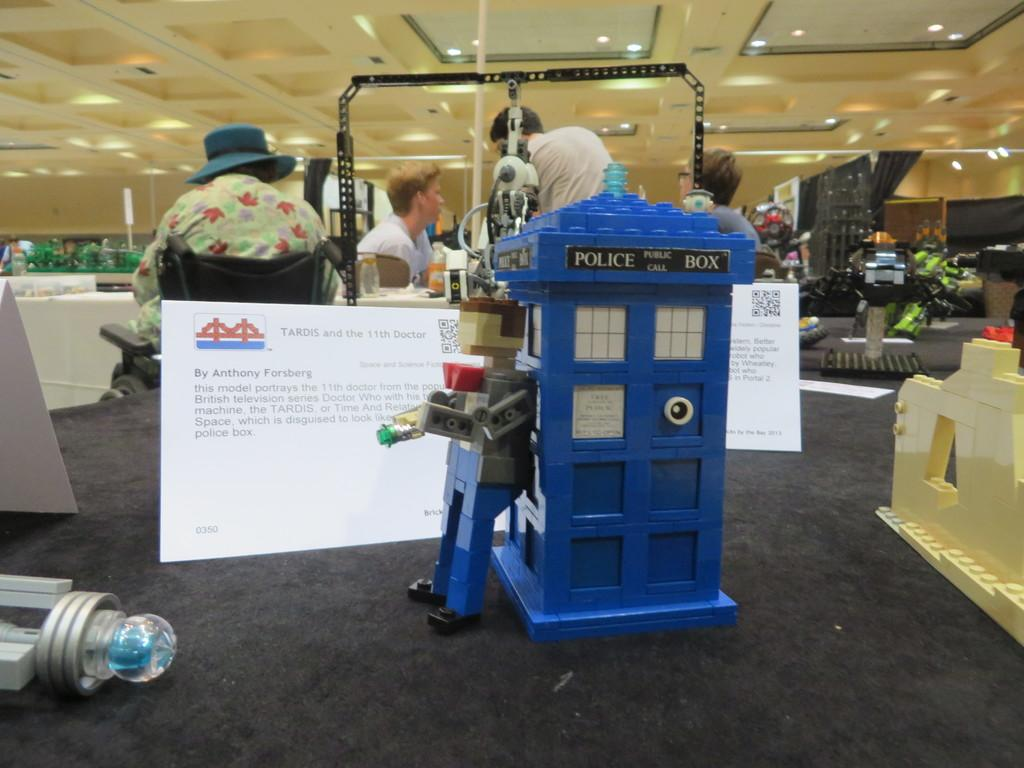What type of objects can be seen in the image? There are toys and paper notes in the image. Are there any people visible in the image? Yes, people are present in the image. What other objects can be seen in the image besides toys and paper notes? There are other objects in the image. What can be seen at the top of the image? There are lights visible at the top of the image. What type of food is being prepared in the image? There is no food preparation visible in the image. Can you describe the wax sculpture in the image? There is no wax sculpture present in the image. 